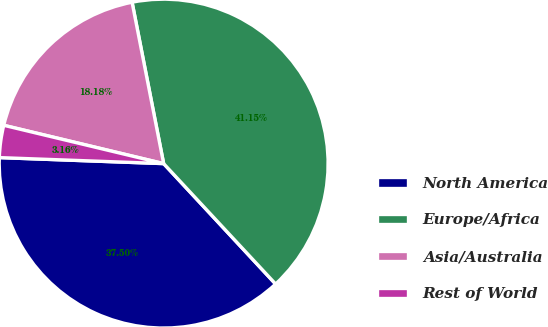Convert chart to OTSL. <chart><loc_0><loc_0><loc_500><loc_500><pie_chart><fcel>North America<fcel>Europe/Africa<fcel>Asia/Australia<fcel>Rest of World<nl><fcel>37.5%<fcel>41.15%<fcel>18.18%<fcel>3.16%<nl></chart> 